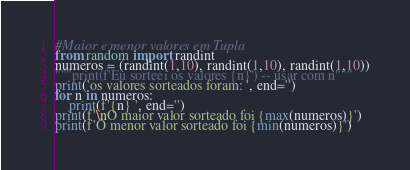<code> <loc_0><loc_0><loc_500><loc_500><_Python_>#Maior e menor valores em Tupla
from random import randint
numeros = (randint(1,10), randint(1,10), randint(1,10))
"""print(f'Eu sorteei os valores {n}') -- usar com n"""
print('os valores sorteados foram: ', end='')
for n in numeros:
    print(f'{n} ', end='')
print(f'\nO maior valor sorteado foi {max(numeros)}')
print(f'O menor valor sorteado foi {min(numeros)}')</code> 